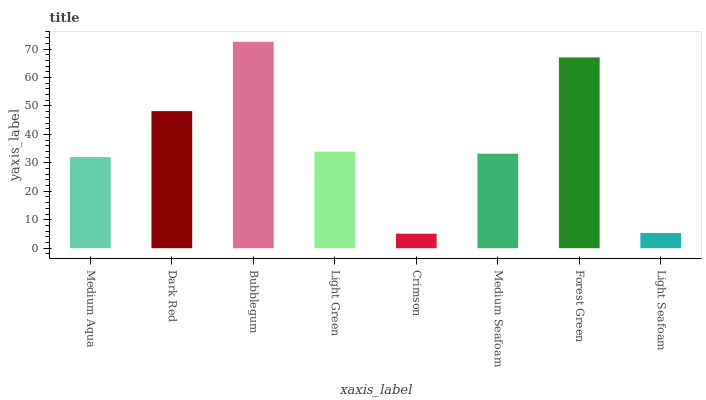Is Crimson the minimum?
Answer yes or no. Yes. Is Bubblegum the maximum?
Answer yes or no. Yes. Is Dark Red the minimum?
Answer yes or no. No. Is Dark Red the maximum?
Answer yes or no. No. Is Dark Red greater than Medium Aqua?
Answer yes or no. Yes. Is Medium Aqua less than Dark Red?
Answer yes or no. Yes. Is Medium Aqua greater than Dark Red?
Answer yes or no. No. Is Dark Red less than Medium Aqua?
Answer yes or no. No. Is Light Green the high median?
Answer yes or no. Yes. Is Medium Seafoam the low median?
Answer yes or no. Yes. Is Dark Red the high median?
Answer yes or no. No. Is Light Seafoam the low median?
Answer yes or no. No. 